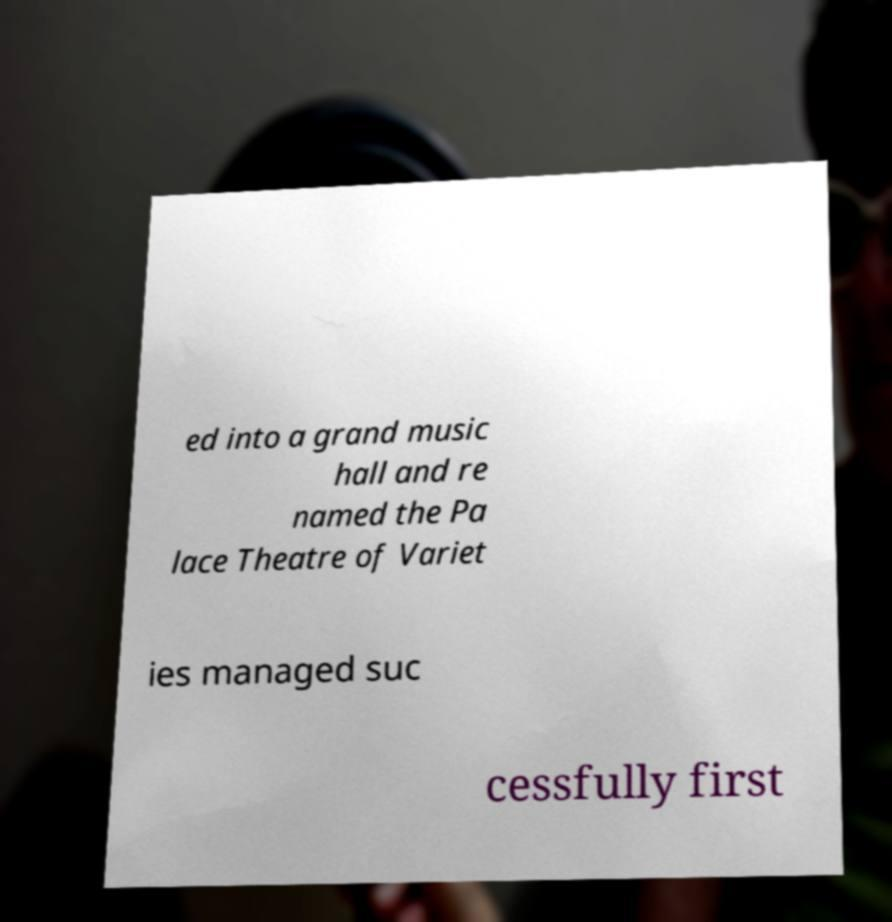I need the written content from this picture converted into text. Can you do that? ed into a grand music hall and re named the Pa lace Theatre of Variet ies managed suc cessfully first 